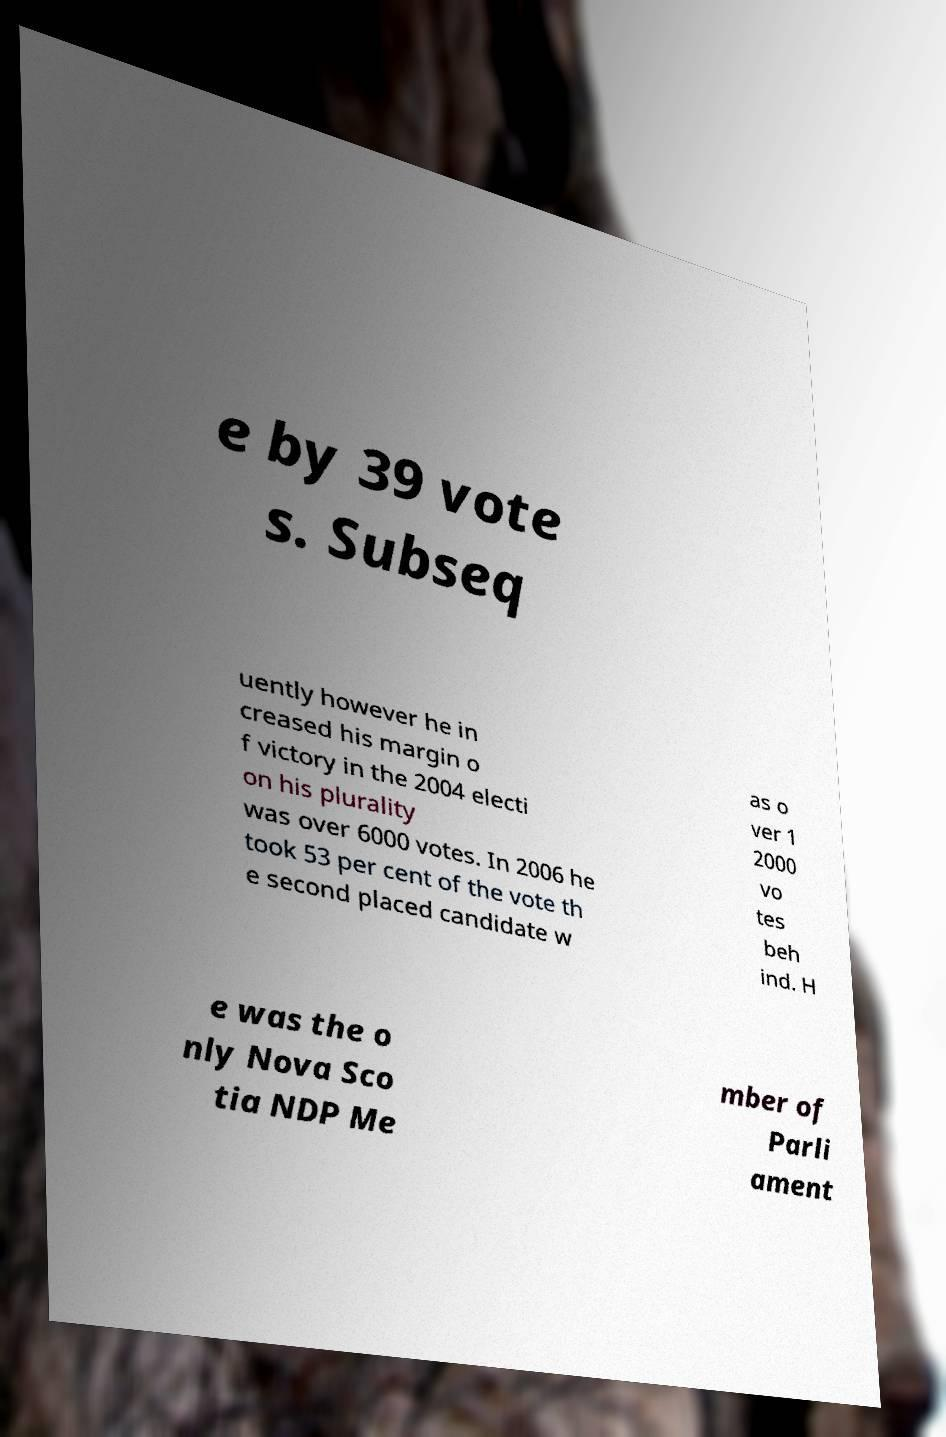Could you assist in decoding the text presented in this image and type it out clearly? e by 39 vote s. Subseq uently however he in creased his margin o f victory in the 2004 electi on his plurality was over 6000 votes. In 2006 he took 53 per cent of the vote th e second placed candidate w as o ver 1 2000 vo tes beh ind. H e was the o nly Nova Sco tia NDP Me mber of Parli ament 